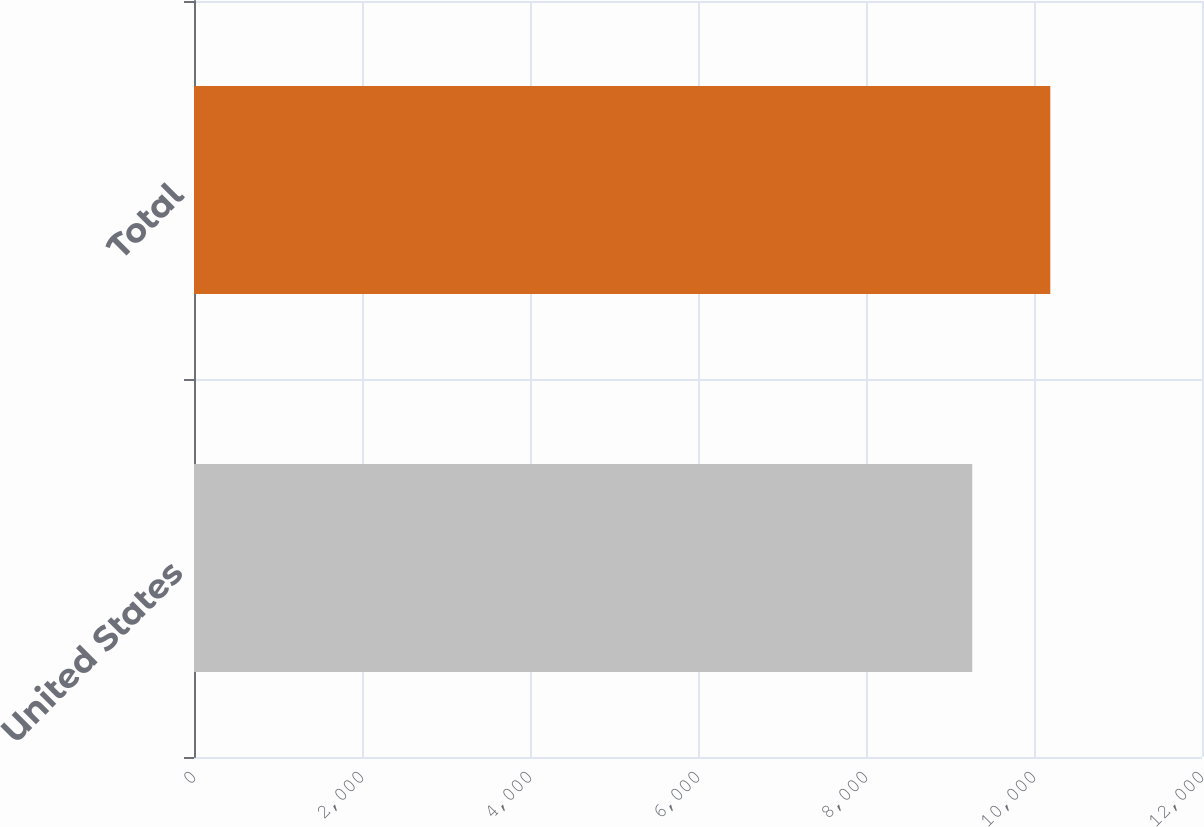Convert chart to OTSL. <chart><loc_0><loc_0><loc_500><loc_500><bar_chart><fcel>United States<fcel>Total<nl><fcel>9265<fcel>10194<nl></chart> 